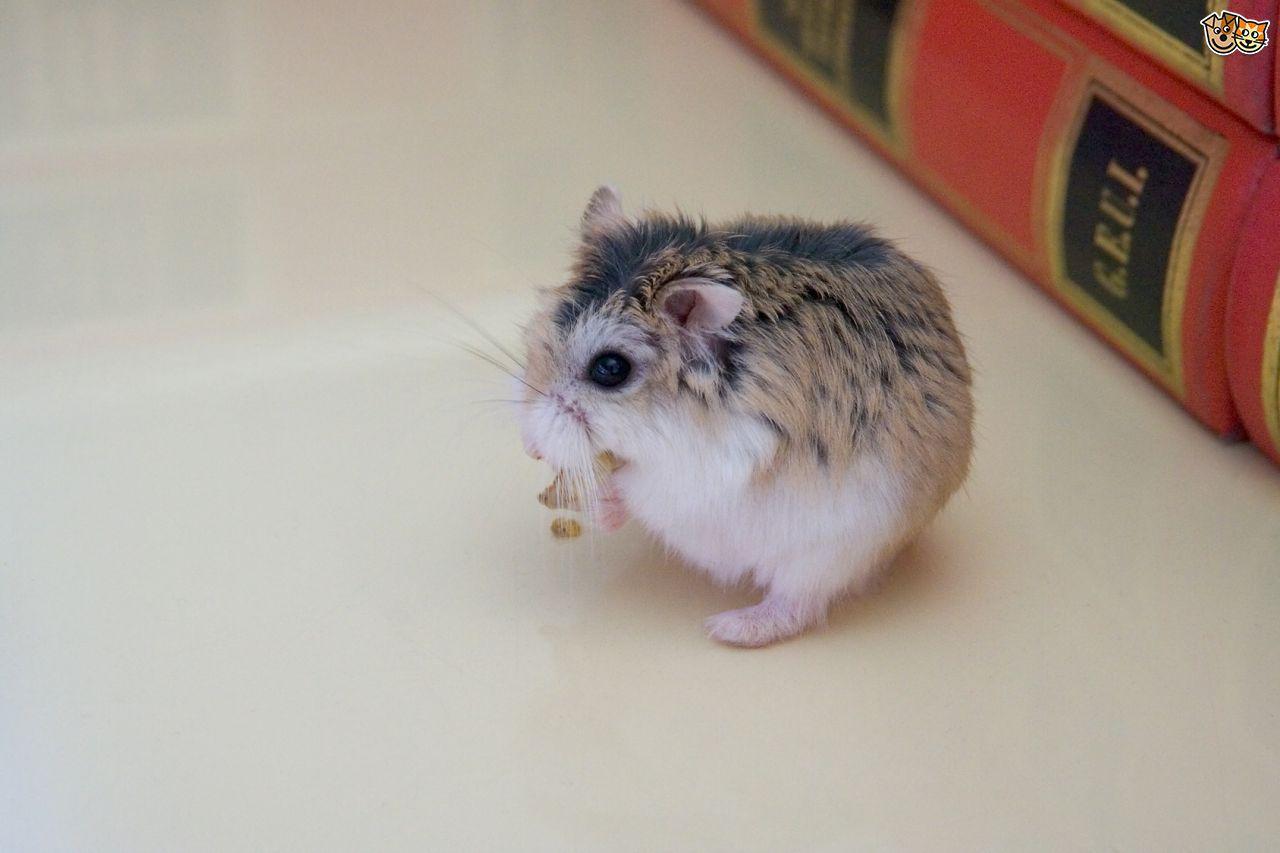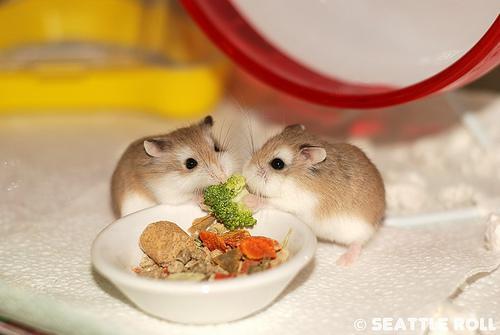The first image is the image on the left, the second image is the image on the right. Evaluate the accuracy of this statement regarding the images: "There are no more than two mice eating out of a tray/bowl.". Is it true? Answer yes or no. Yes. The first image is the image on the left, the second image is the image on the right. Considering the images on both sides, is "There are no more than 2 hamsters in the image pair" valid? Answer yes or no. No. 